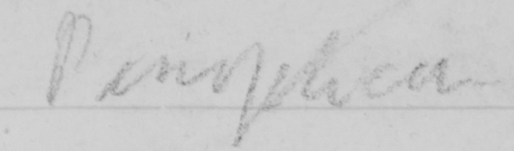What text is written in this handwritten line? Panopticon 